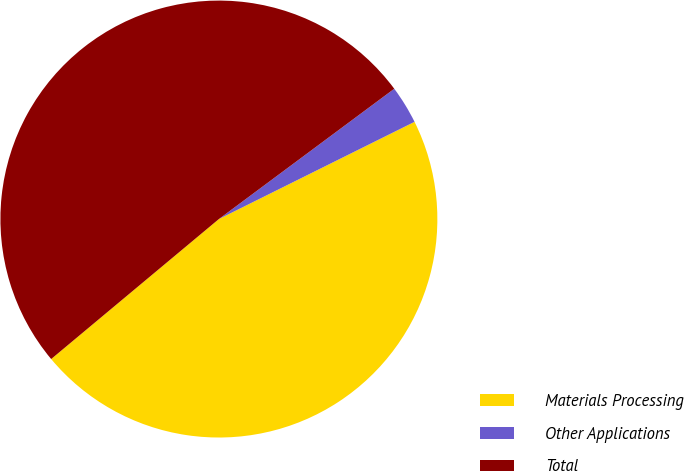Convert chart to OTSL. <chart><loc_0><loc_0><loc_500><loc_500><pie_chart><fcel>Materials Processing<fcel>Other Applications<fcel>Total<nl><fcel>46.27%<fcel>2.83%<fcel>50.9%<nl></chart> 